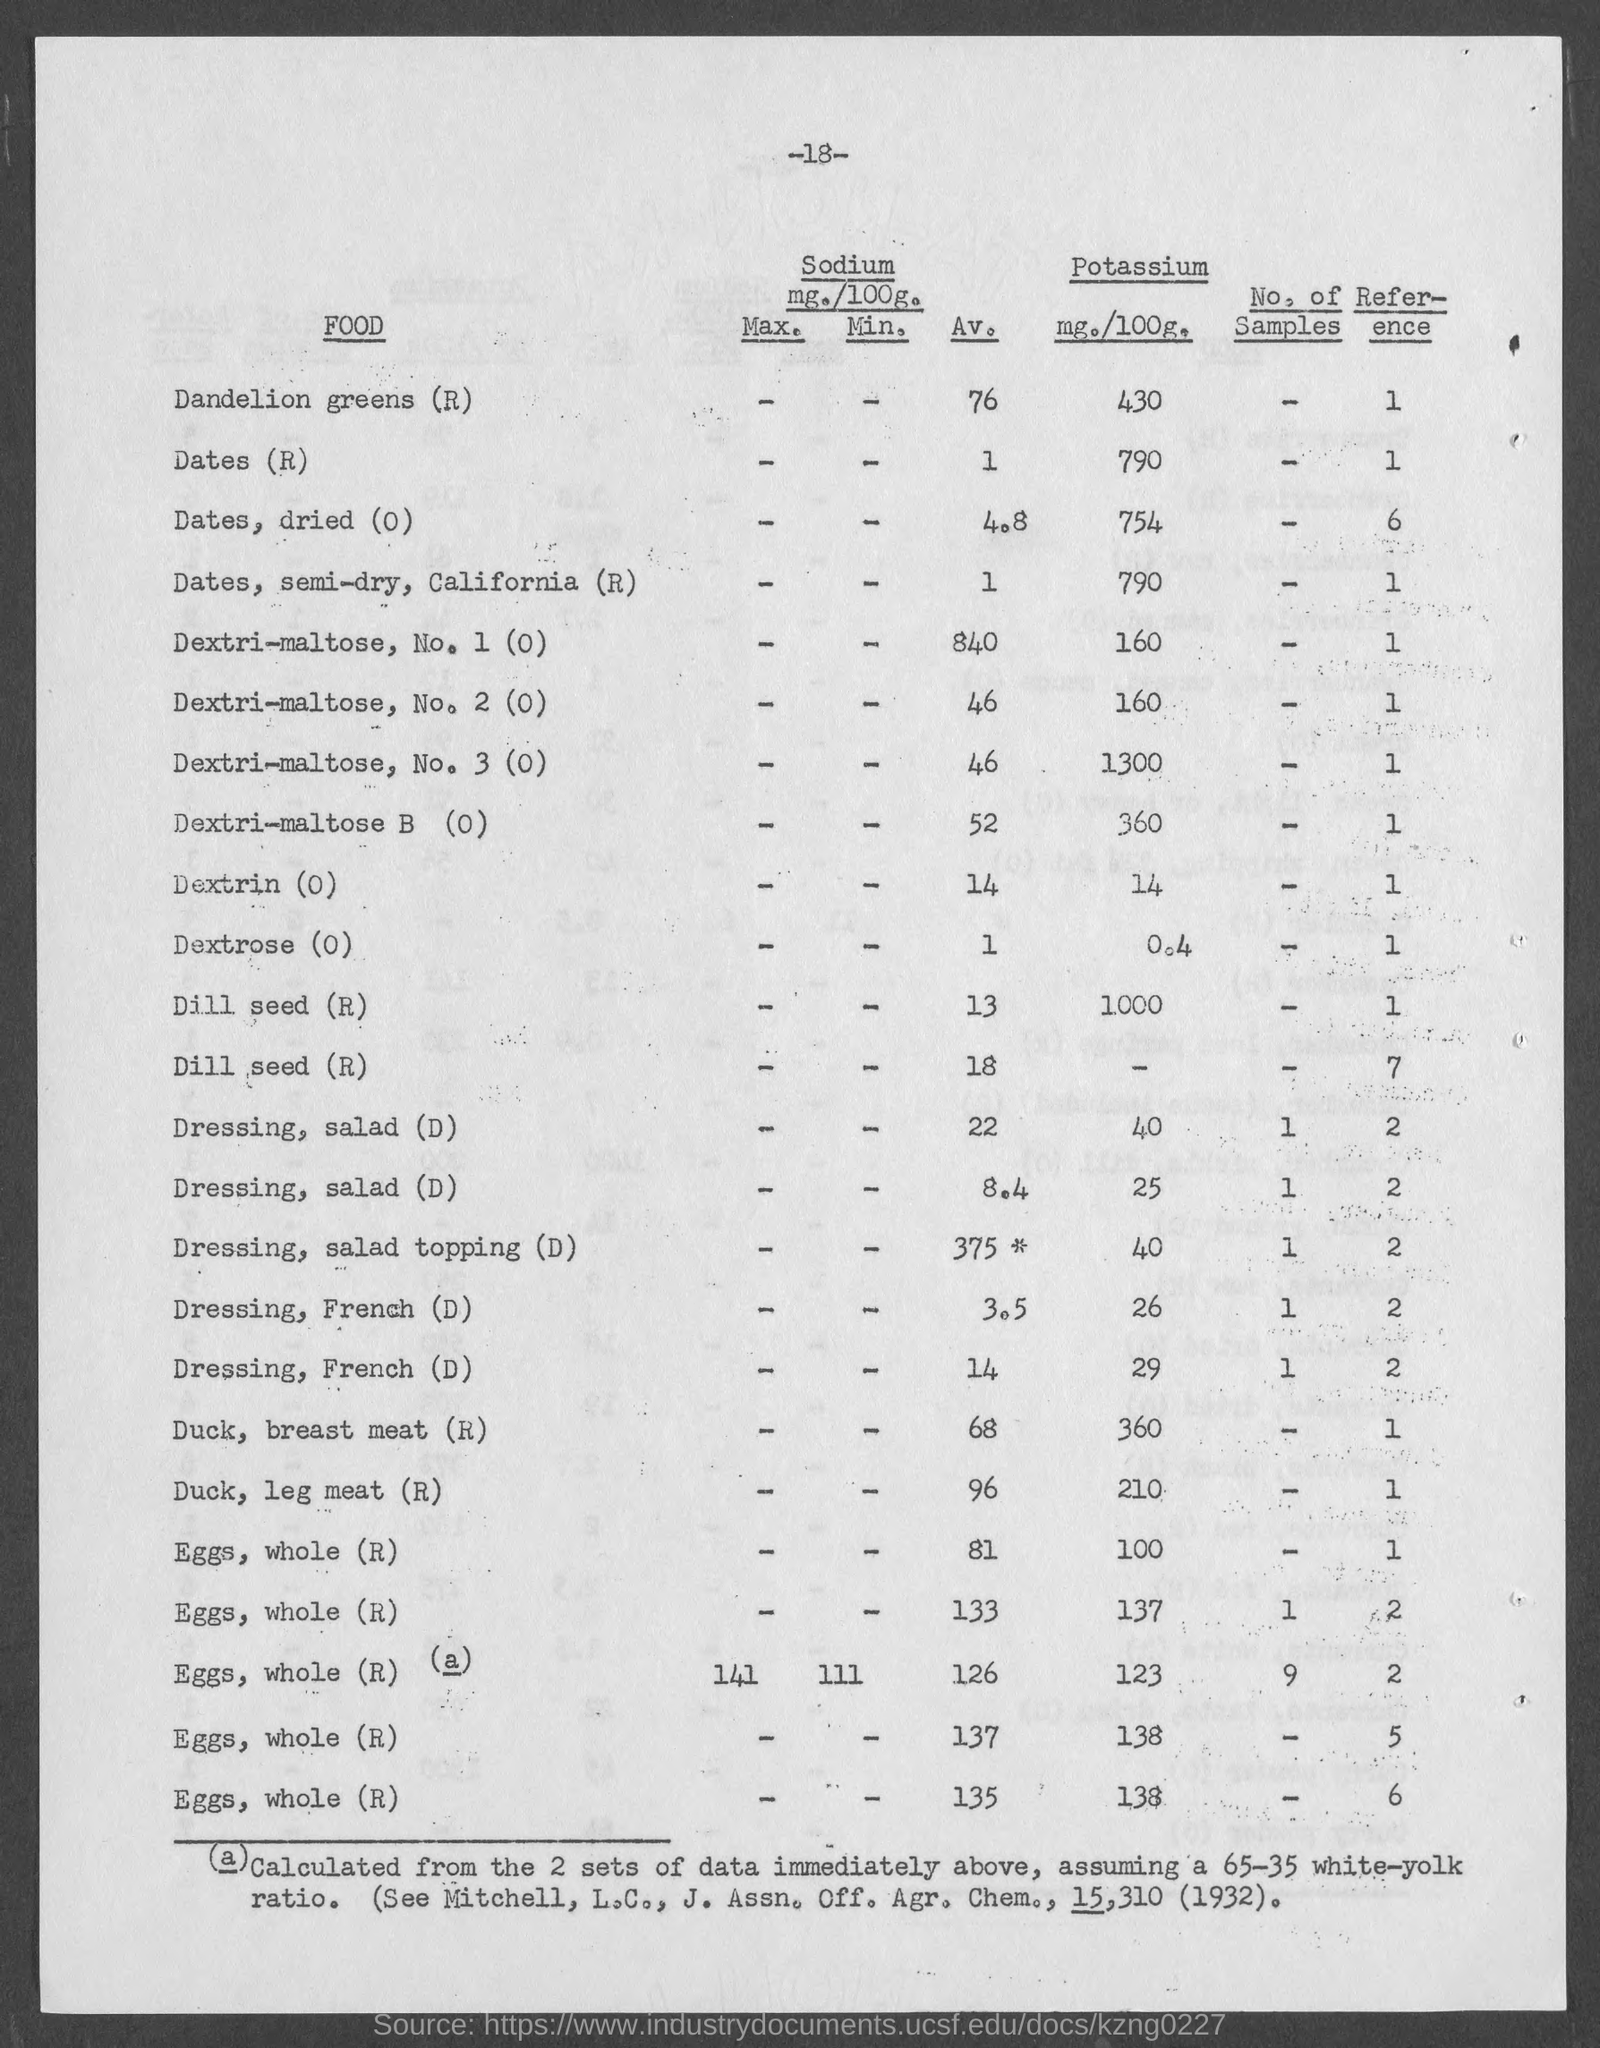Identify some key points in this picture. The maximum sodium value of whole eggs is 141 milligrams per serving. 